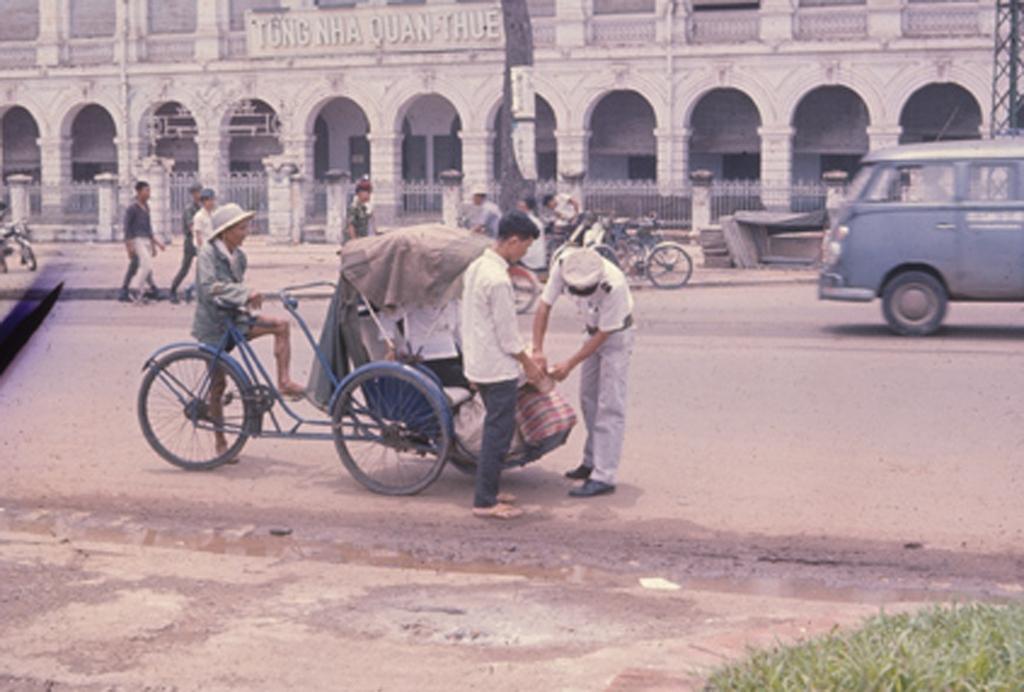How would you summarize this image in a sentence or two? There is a person holding a cycle with a cart. Another two persons are standing and holding a bag. And the person holding the cycle is wearing a hat. Behind them there are persons, vehicles, cycles and a building. There are pillars for the building. There are railings near the building. 